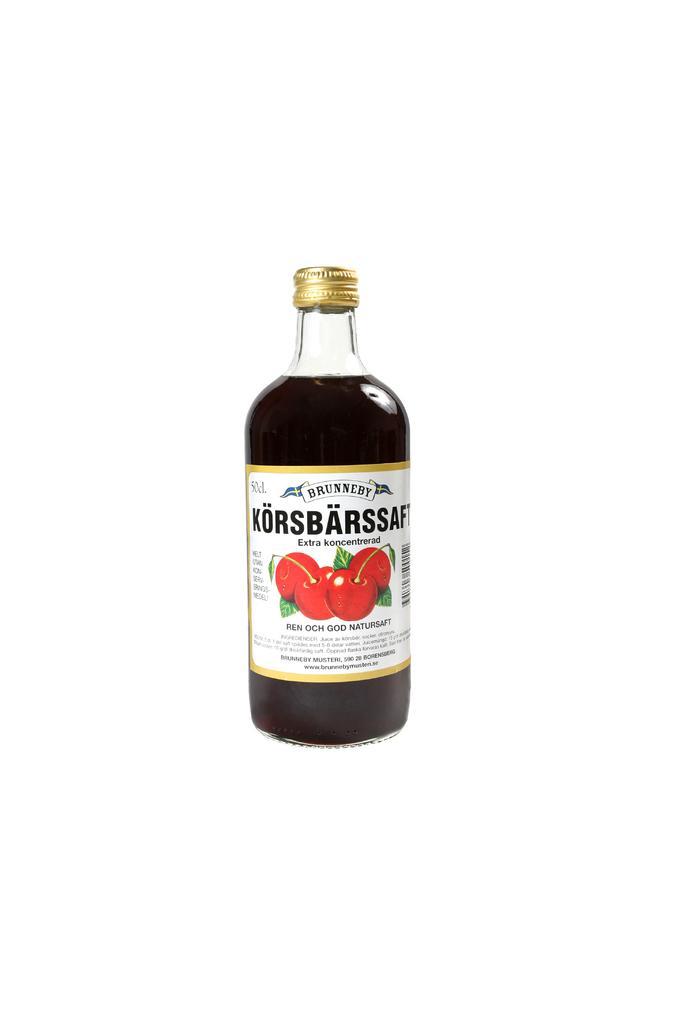Could you give a brief overview of what you see in this image? In this image we can see a bottle with a label on it. 